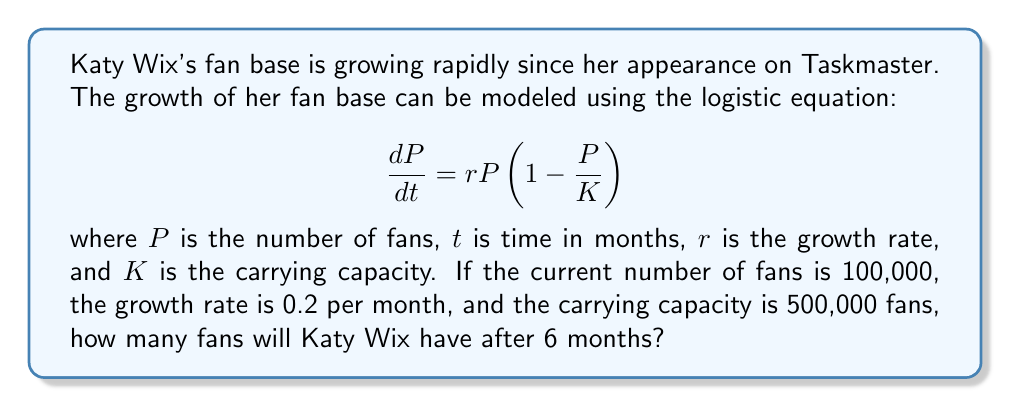Teach me how to tackle this problem. To solve this problem, we need to use the solution to the logistic equation, which is given by:

$$P(t) = \frac{KP_0e^{rt}}{K + P_0(e^{rt} - 1)}$$

Where:
$P(t)$ is the population at time $t$
$K$ is the carrying capacity (500,000)
$P_0$ is the initial population (100,000)
$r$ is the growth rate (0.2 per month)
$t$ is the time in months (6)

Let's substitute these values into the equation:

$$P(6) = \frac{500,000 \cdot 100,000 \cdot e^{0.2 \cdot 6}}{500,000 + 100,000(e^{0.2 \cdot 6} - 1)}$$

Now, let's solve this step-by-step:

1. Calculate $e^{0.2 \cdot 6}$:
   $e^{1.2} \approx 3.3201$

2. Substitute this value:
   $$P(6) = \frac{500,000 \cdot 100,000 \cdot 3.3201}{500,000 + 100,000(3.3201 - 1)}$$

3. Simplify:
   $$P(6) = \frac{16,600,500,000}{500,000 + 232,010}$$
   $$P(6) = \frac{16,600,500,000}{732,010}$$

4. Divide:
   $$P(6) \approx 22,677.95$$

5. Round to the nearest whole number:
   $$P(6) \approx 22,678$$
Answer: After 6 months, Katy Wix will have approximately 22,678 fans. 